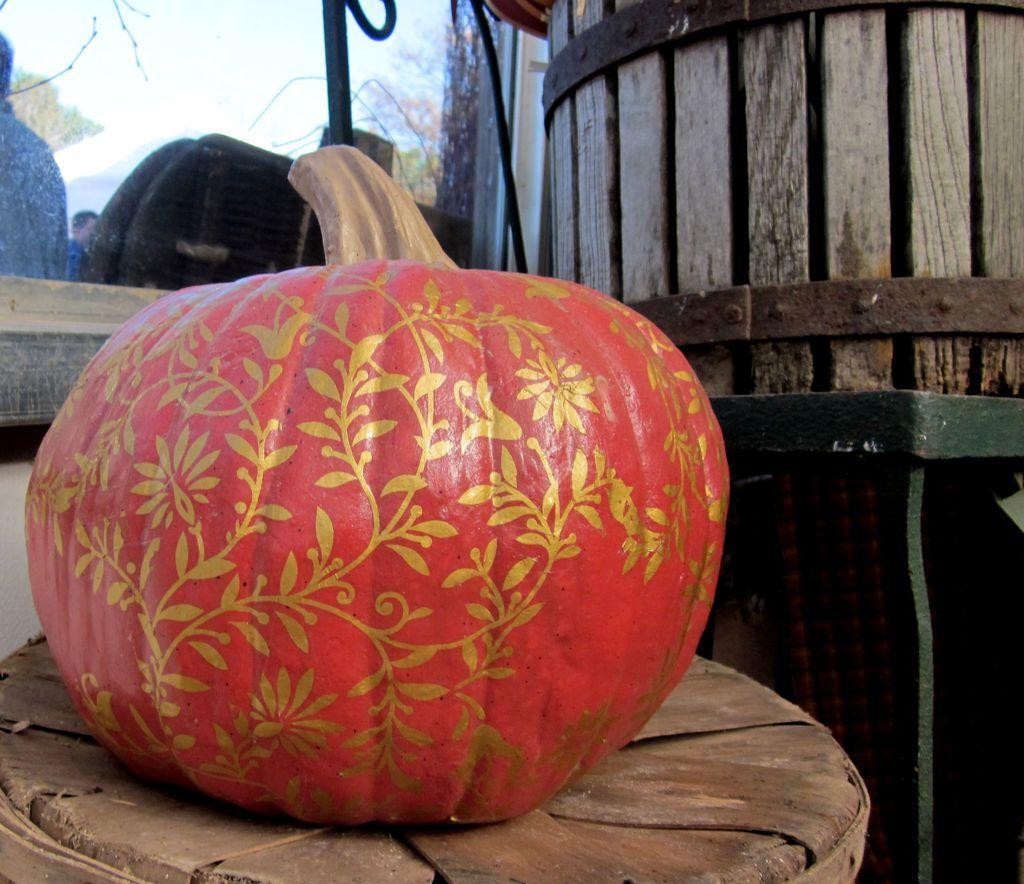How would you summarize this image in a sentence or two? In this picture we can see a pumpkin on the table, beside to the table we can find a barrel and metal rods, in the background we can see few chairs, trees and group of people. 